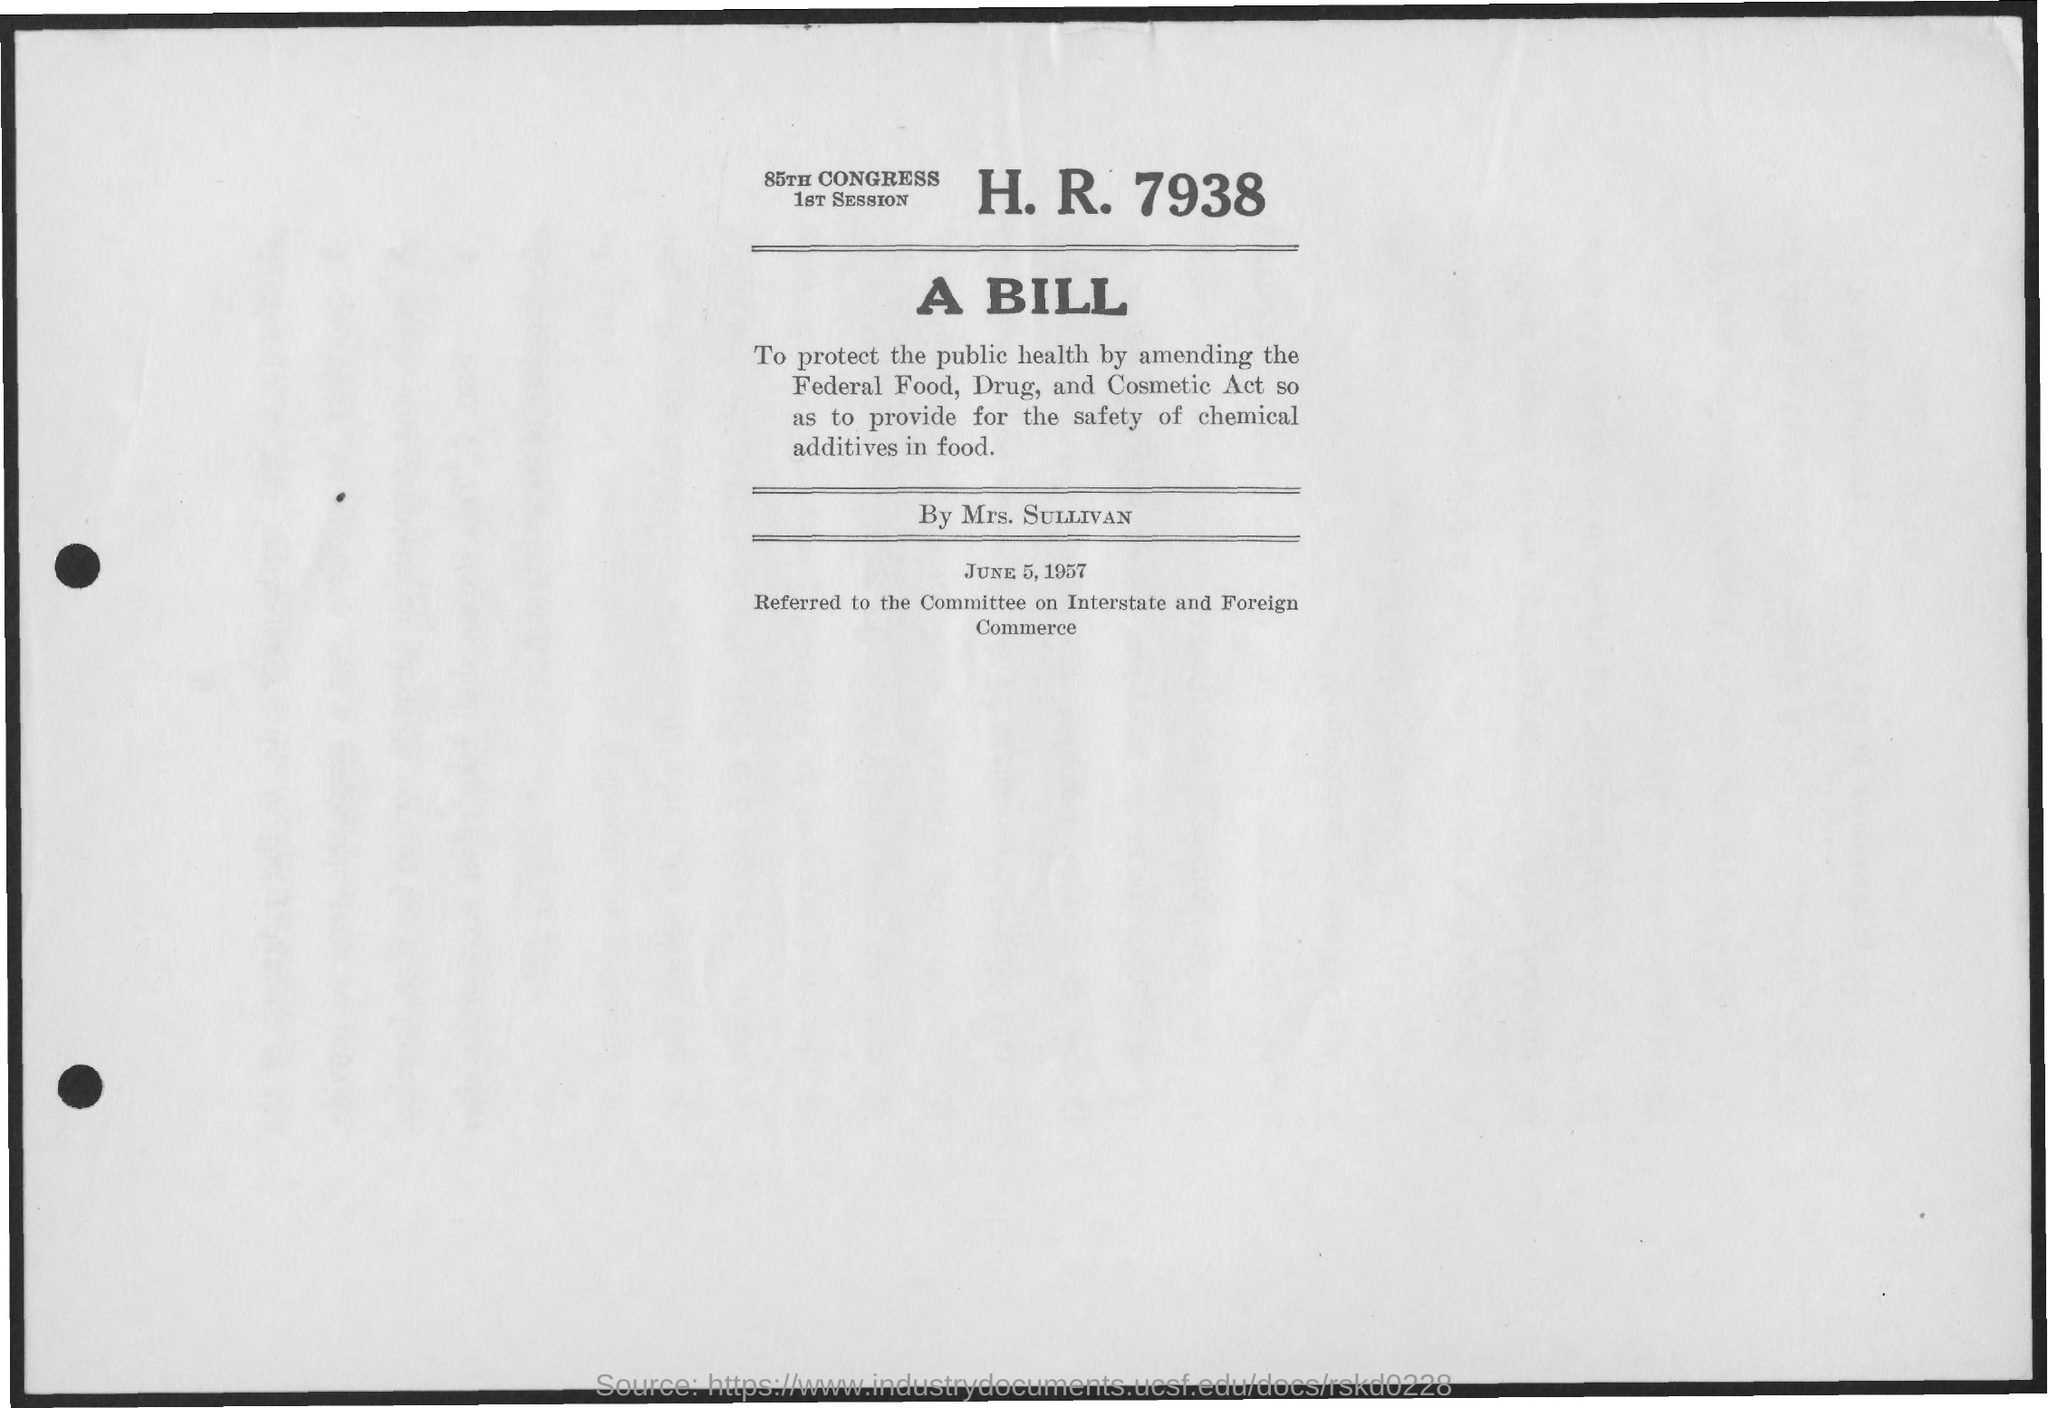Point out several critical features in this image. The document is dated June 5, 1957. 